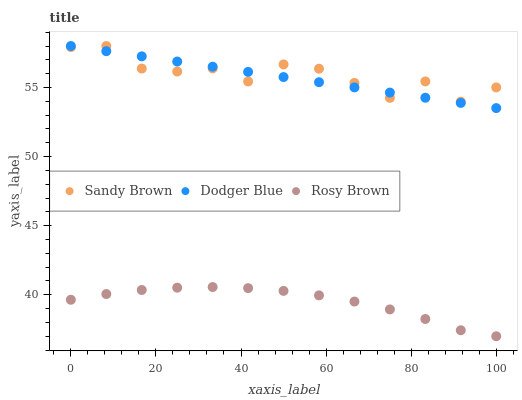Does Rosy Brown have the minimum area under the curve?
Answer yes or no. Yes. Does Sandy Brown have the maximum area under the curve?
Answer yes or no. Yes. Does Sandy Brown have the minimum area under the curve?
Answer yes or no. No. Does Rosy Brown have the maximum area under the curve?
Answer yes or no. No. Is Dodger Blue the smoothest?
Answer yes or no. Yes. Is Sandy Brown the roughest?
Answer yes or no. Yes. Is Rosy Brown the smoothest?
Answer yes or no. No. Is Rosy Brown the roughest?
Answer yes or no. No. Does Rosy Brown have the lowest value?
Answer yes or no. Yes. Does Sandy Brown have the lowest value?
Answer yes or no. No. Does Sandy Brown have the highest value?
Answer yes or no. Yes. Does Rosy Brown have the highest value?
Answer yes or no. No. Is Rosy Brown less than Sandy Brown?
Answer yes or no. Yes. Is Sandy Brown greater than Rosy Brown?
Answer yes or no. Yes. Does Sandy Brown intersect Dodger Blue?
Answer yes or no. Yes. Is Sandy Brown less than Dodger Blue?
Answer yes or no. No. Is Sandy Brown greater than Dodger Blue?
Answer yes or no. No. Does Rosy Brown intersect Sandy Brown?
Answer yes or no. No. 